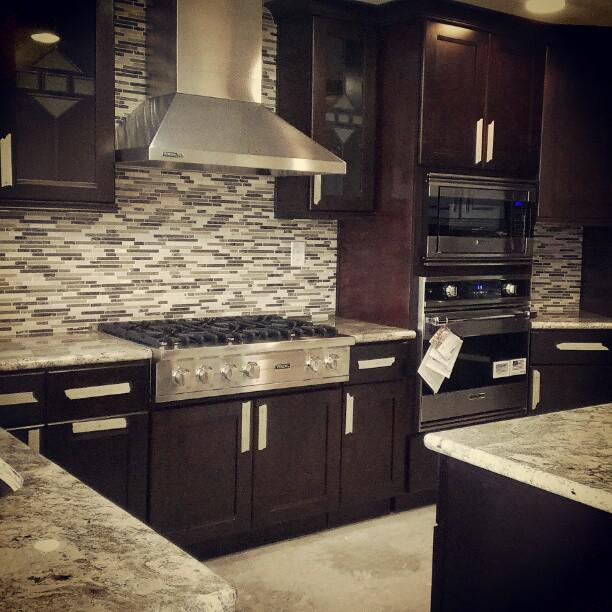Question: where is this located?
Choices:
A. Bathroom.
B. Bedroom.
C. Living Room.
D. Kitchen.
Answer with the letter. Answer: D Question: how many ovens are there?
Choices:
A. Two.
B. Four.
C. One.
D. Three.
Answer with the letter. Answer: A Question: what is on the stove?
Choices:
A. Knobs.
B. Burner grates.
C. Drip pans.
D. Manufacturers information.
Answer with the letter. Answer: D Question: what are the counter tops made of?
Choices:
A. Granite.
B. Corian.
C. Formica.
D. Marble.
Answer with the letter. Answer: A Question: what type of stove is this?
Choices:
A. Electric.
B. Wood-burning.
C. Freestanding range.
D. Gas.
Answer with the letter. Answer: D Question: what is on the cabinets?
Choices:
A. Manufacturers information.
B. Protective plastic film.
C. Material tags.
D. Tape.
Answer with the letter. Answer: D Question: how opulent is the black kitchen?
Choices:
A. Somewhat.
B. It is not.
C. A little bit.
D. Very opulent.
Answer with the letter. Answer: D Question: why does the backsplash have tiles?
Choices:
A. For style.
B. For upgrade.
C. To be creative.
D. For decoration.
Answer with the letter. Answer: D Question: what are the cabinets made out of?
Choices:
A. Wood.
B. Plastic.
C. Cedar.
D. Pine.
Answer with the letter. Answer: A Question: why are there tags on the stove?
Choices:
A. It is new.
B. Never took them off.
C. Children's stickers.
D. Something sticky.
Answer with the letter. Answer: A Question: what cabinets have decorative doors?
Choices:
A. The bottom cabinets.
B. The upper cabinets.
C. The new cabinets.
D. The bathroom cabinets.
Answer with the letter. Answer: B Question: what kind of kitchen is this?
Choices:
A. A modern kitchen.
B. An old fashioned kitchen.
C. An open kitchen.
D. A small kitchen.
Answer with the letter. Answer: A Question: how many knobs are on the range?
Choices:
A. Four.
B. Five.
C. Seven.
D. Six.
Answer with the letter. Answer: D Question: what is the kitchen?
Choices:
A. Brand new or newly remodeled.
B. Rusty.
C. Falling apart.
D. In repair.
Answer with the letter. Answer: A Question: what kind of stove is this?
Choices:
A. Electric.
B. Wood burning.
C. Gas.
D. Coal.
Answer with the letter. Answer: C Question: what is marble?
Choices:
A. The floor.
B. The desktop.
C. The mantel.
D. The countertop.
Answer with the letter. Answer: D 